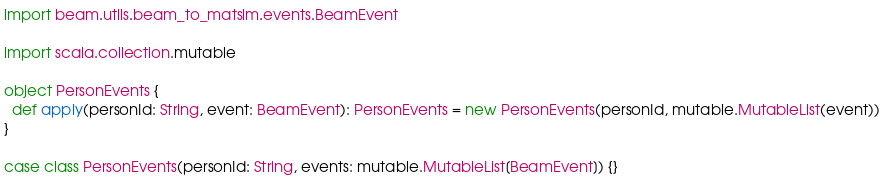<code> <loc_0><loc_0><loc_500><loc_500><_Scala_>
import beam.utils.beam_to_matsim.events.BeamEvent

import scala.collection.mutable

object PersonEvents {
  def apply(personId: String, event: BeamEvent): PersonEvents = new PersonEvents(personId, mutable.MutableList(event))
}

case class PersonEvents(personId: String, events: mutable.MutableList[BeamEvent]) {}
</code> 